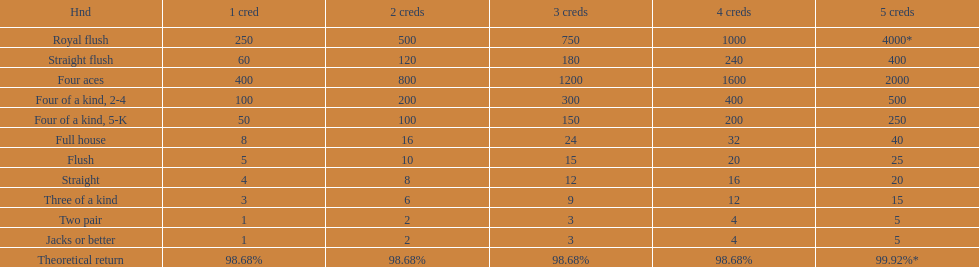Can you parse all the data within this table? {'header': ['Hnd', '1 cred', '2 creds', '3 creds', '4 creds', '5 creds'], 'rows': [['Royal flush', '250', '500', '750', '1000', '4000*'], ['Straight flush', '60', '120', '180', '240', '400'], ['Four aces', '400', '800', '1200', '1600', '2000'], ['Four of a kind, 2-4', '100', '200', '300', '400', '500'], ['Four of a kind, 5-K', '50', '100', '150', '200', '250'], ['Full house', '8', '16', '24', '32', '40'], ['Flush', '5', '10', '15', '20', '25'], ['Straight', '4', '8', '12', '16', '20'], ['Three of a kind', '3', '6', '9', '12', '15'], ['Two pair', '1', '2', '3', '4', '5'], ['Jacks or better', '1', '2', '3', '4', '5'], ['Theoretical return', '98.68%', '98.68%', '98.68%', '98.68%', '99.92%*']]} What is the total amount of a 3 credit straight flush? 180. 